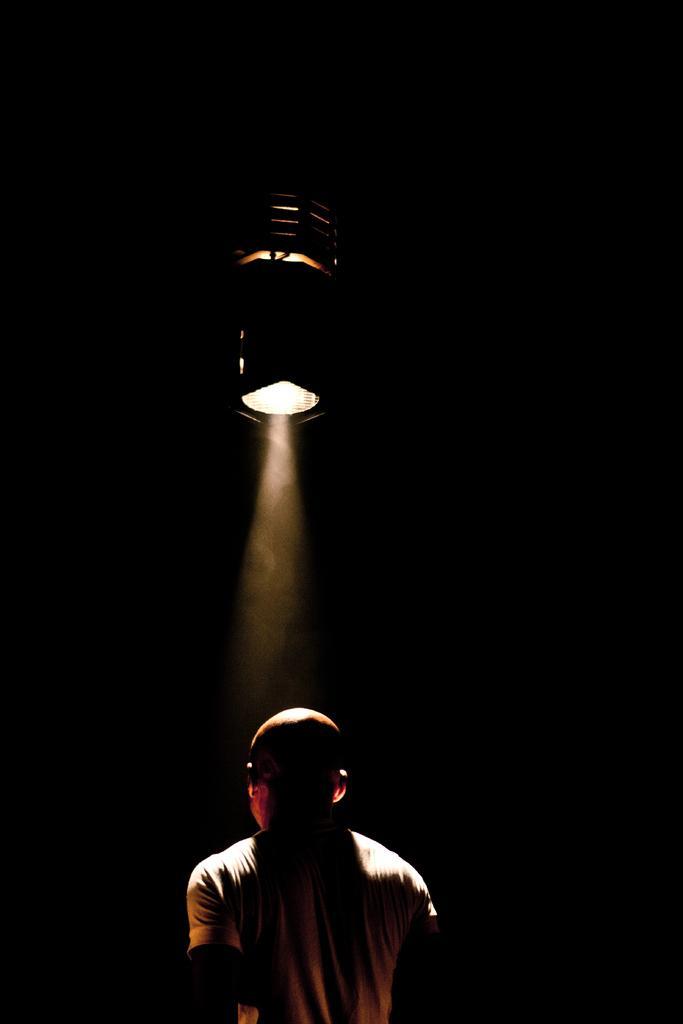Could you give a brief overview of what you see in this image? In the image I can see a person is standing. In the background I can see light and the background of the image is dark. 